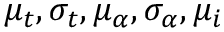Convert formula to latex. <formula><loc_0><loc_0><loc_500><loc_500>\mu _ { t } , \sigma _ { t } , \mu _ { \alpha } , \sigma _ { \alpha } , \mu _ { i }</formula> 